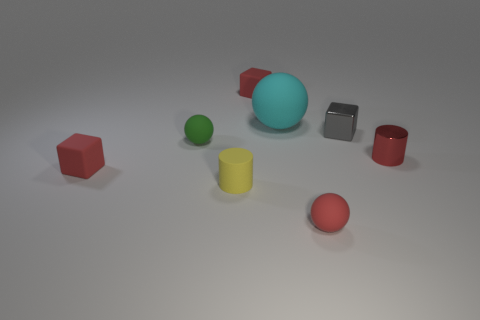Add 1 large blocks. How many objects exist? 9 Subtract all cubes. How many objects are left? 5 Subtract 0 green cylinders. How many objects are left? 8 Subtract all small yellow things. Subtract all small objects. How many objects are left? 0 Add 7 large rubber objects. How many large rubber objects are left? 8 Add 7 cyan metallic cylinders. How many cyan metallic cylinders exist? 7 